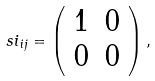<formula> <loc_0><loc_0><loc_500><loc_500>\ s i _ { i j } = \left ( \begin{array} { c c } 1 & 0 \\ 0 & 0 \end{array} \right ) ,</formula> 